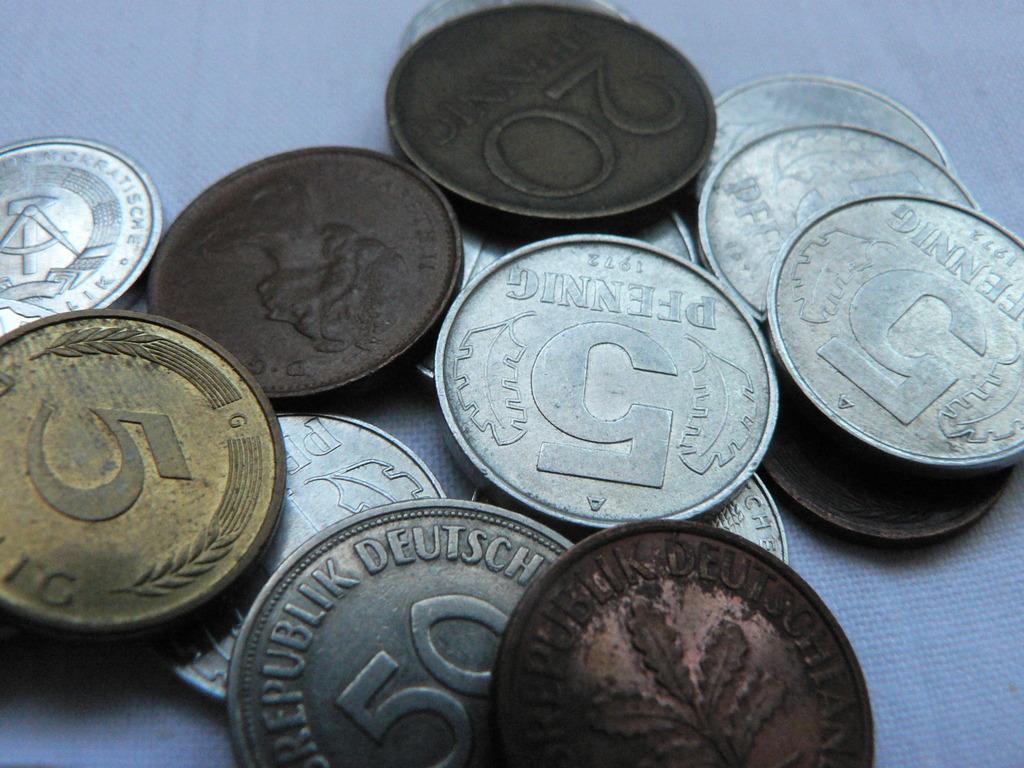What number is on the gold coin?
Your answer should be compact. 5. Which country own these coins?
Ensure brevity in your answer.  Germany. 